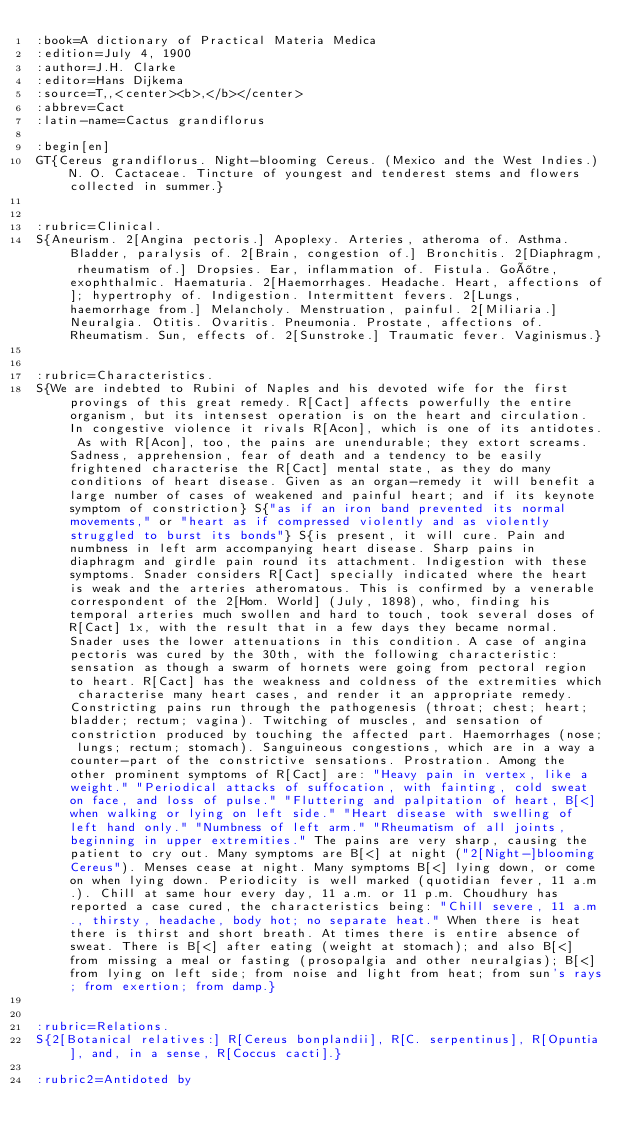<code> <loc_0><loc_0><loc_500><loc_500><_ObjectiveC_>:book=A dictionary of Practical Materia Medica
:edition=July 4, 1900
:author=J.H. Clarke
:editor=Hans Dijkema
:source=T,,<center><b>,</b></center>
:abbrev=Cact
:latin-name=Cactus grandiflorus

:begin[en]
GT{Cereus grandiflorus. Night-blooming Cereus. (Mexico and the West Indies.) N. O. Cactaceae. Tincture of youngest and tenderest stems and flowers collected in summer.}


:rubric=Clinical.
S{Aneurism. 2[Angina pectoris.] Apoplexy. Arteries, atheroma of. Asthma. Bladder, paralysis of. 2[Brain, congestion of.] Bronchitis. 2[Diaphragm, rheumatism of.] Dropsies. Ear, inflammation of. Fistula. Goître, exophthalmic. Haematuria. 2[Haemorrhages. Headache. Heart, affections of]; hypertrophy of. Indigestion. Intermittent fevers. 2[Lungs, haemorrhage from.] Melancholy. Menstruation, painful. 2[Miliaria.] Neuralgia. Otitis. Ovaritis. Pneumonia. Prostate, affections of. Rheumatism. Sun, effects of. 2[Sunstroke.] Traumatic fever. Vaginismus.}


:rubric=Characteristics.
S{We are indebted to Rubini of Naples and his devoted wife for the first provings of this great remedy. R[Cact] affects powerfully the entire organism, but its intensest operation is on the heart and circulation. In congestive violence it rivals R[Acon], which is one of its antidotes. As with R[Acon], too, the pains are unendurable; they extort screams. Sadness, apprehension, fear of death and a tendency to be easily frightened characterise the R[Cact] mental state, as they do many conditions of heart disease. Given as an organ-remedy it will benefit a large number of cases of weakened and painful heart; and if its keynote symptom of constriction} S{"as if an iron band prevented its normal movements," or "heart as if compressed violently and as violently struggled to burst its bonds"} S{is present, it will cure. Pain and numbness in left arm accompanying heart disease. Sharp pains in diaphragm and girdle pain round its attachment. Indigestion with these symptoms. Snader considers R[Cact] specially indicated where the heart is weak and the arteries atheromatous. This is confirmed by a venerable correspondent of the 2[Hom. World] (July, 1898), who, finding his temporal arteries much swollen and hard to touch, took several doses of R[Cact] 1x, with the result that in a few days they became normal. Snader uses the lower attenuations in this condition. A case of angina pectoris was cured by the 30th, with the following characteristic: sensation as though a swarm of hornets were going from pectoral region to heart. R[Cact] has the weakness and coldness of the extremities which characterise many heart cases, and render it an appropriate remedy. Constricting pains run through the pathogenesis (throat; chest; heart; bladder; rectum; vagina). Twitching of muscles, and sensation of constriction produced by touching the affected part. Haemorrhages (nose; lungs; rectum; stomach). Sanguineous congestions, which are in a way a counter-part of the constrictive sensations. Prostration. Among the other prominent symptoms of R[Cact] are: "Heavy pain in vertex, like a weight." "Periodical attacks of suffocation, with fainting, cold sweat on face, and loss of pulse." "Fluttering and palpitation of heart, B[<] when walking or lying on left side." "Heart disease with swelling of left hand only." "Numbness of left arm." "Rheumatism of all joints, beginning in upper extremities." The pains are very sharp, causing the patient to cry out. Many symptoms are B[<] at night ("2[Night-]blooming Cereus"). Menses cease at night. Many symptoms B[<] lying down, or come on when lying down. Periodicity is well marked (quotidian fever, 11 a.m.). Chill at same hour every day, 11 a.m. or 11 p.m. Choudhury has reported a case cured, the characteristics being: "Chill severe, 11 a.m., thirsty, headache, body hot; no separate heat." When there is heat there is thirst and short breath. At times there is entire absence of sweat. There is B[<] after eating (weight at stomach); and also B[<] from missing a meal or fasting (prosopalgia and other neuralgias); B[<] from lying on left side; from noise and light from heat; from sun's rays; from exertion; from damp.}


:rubric=Relations.
S{2[Botanical relatives:] R[Cereus bonplandii], R[C. serpentinus], R[Opuntia], and, in a sense, R[Coccus cacti].}

:rubric2=Antidoted by
</code> 